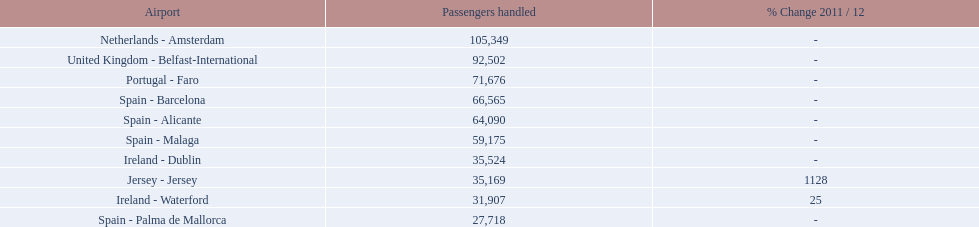Between the topped ranked airport, netherlands - amsterdam, & spain - palma de mallorca, what is the difference in the amount of passengers handled? 77,631. 